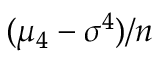<formula> <loc_0><loc_0><loc_500><loc_500>( \mu _ { 4 } - \sigma ^ { 4 } ) / n</formula> 